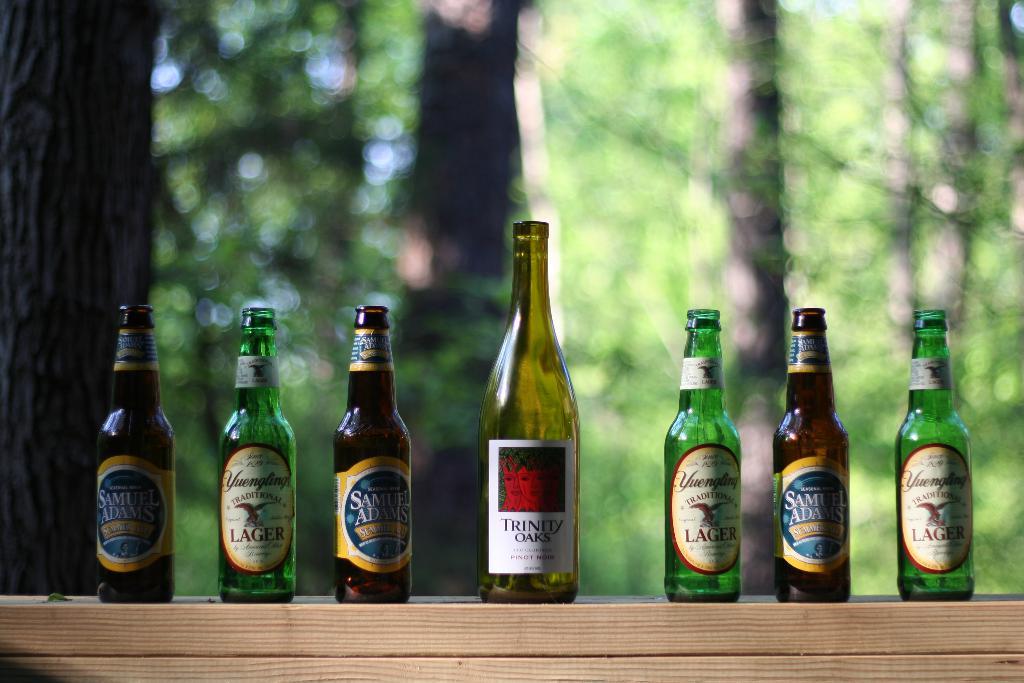What is the brand of the bottle on the middle?
Give a very brief answer. Trinity oaks. 